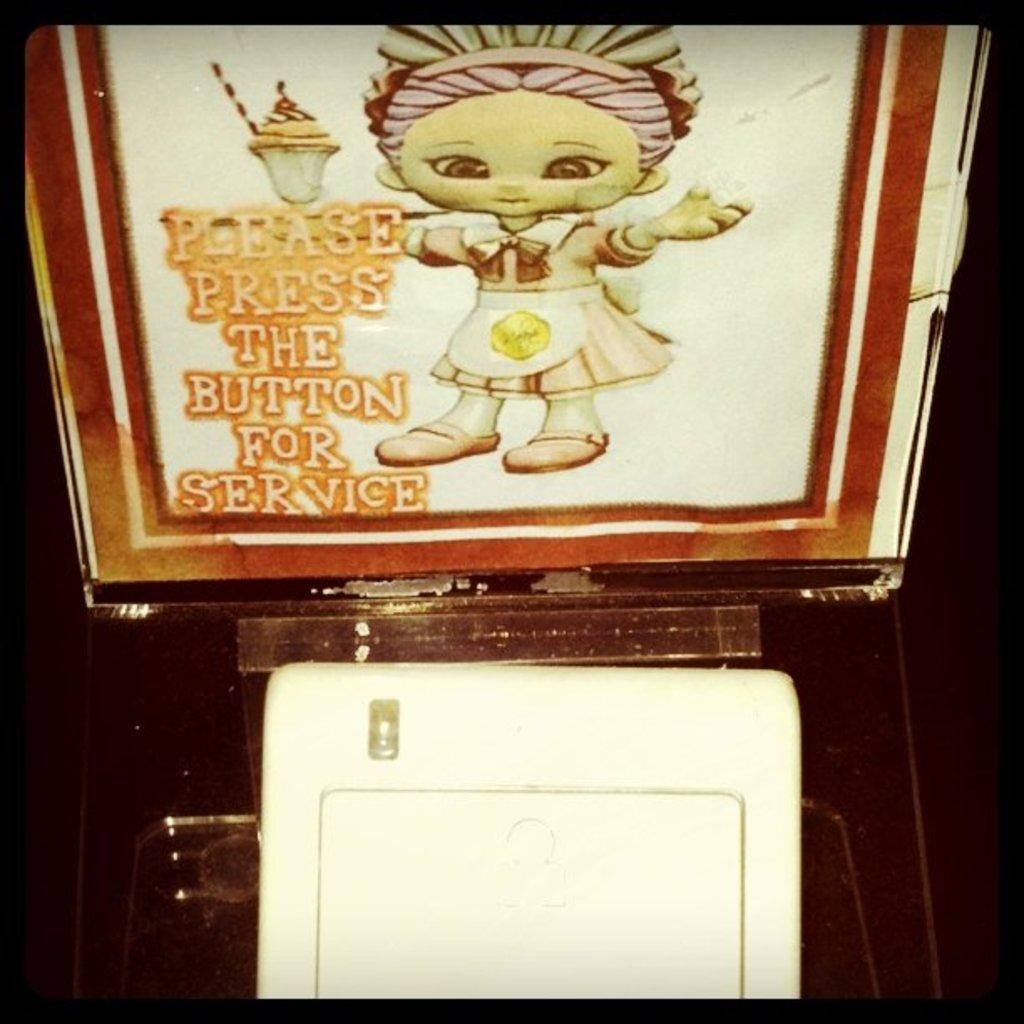Please provide a concise description of this image. This looks like a poster, which is attached to the board. I can see a white color object, which is placed in front of the board. 